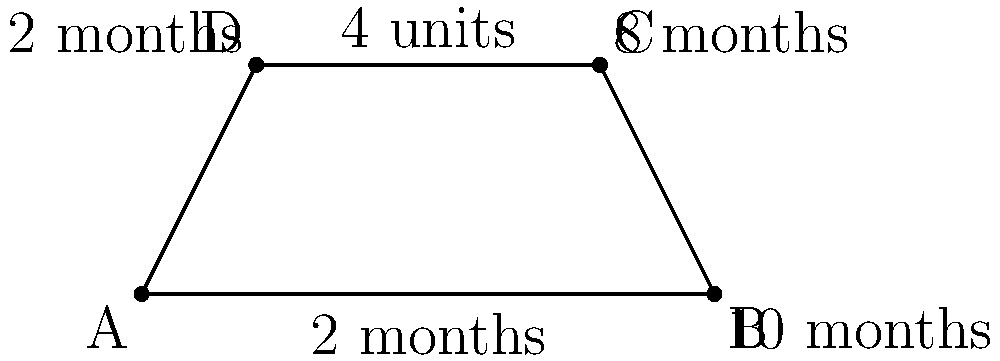As a personal finance blogger, you've designed a trapezoid-shaped budget plan to illustrate how savings can grow over time. The base of the trapezoid represents 10 months, while the top represents 8 months. The height of the trapezoid is 4 units, representing the growth in savings. If each unit of area represents $500 in savings, what is the total amount saved over this period according to your unconventional budget plan? To solve this problem, we need to follow these steps:

1. Recognize that we're dealing with a trapezoid and recall the formula for its area:
   $$A = \frac{1}{2}(b_1 + b_2)h$$
   where $A$ is the area, $b_1$ and $b_2$ are the parallel sides, and $h$ is the height.

2. Identify the values from the diagram:
   $b_1 = 10$ months
   $b_2 = 8$ months
   $h = 4$ units

3. Calculate the area of the trapezoid:
   $$A = \frac{1}{2}(10 + 8) \times 4 = \frac{1}{2} \times 18 \times 4 = 36$$ square units

4. Since each unit of area represents $500 in savings, multiply the area by $500:
   $$\text{Total Savings} = 36 \times $500 = $18,000$$

This unconventional budget plan shows how savings can grow non-linearly over time, potentially inspiring a novel about the complex relationship between time, effort, and wealth accumulation.
Answer: $18,000 